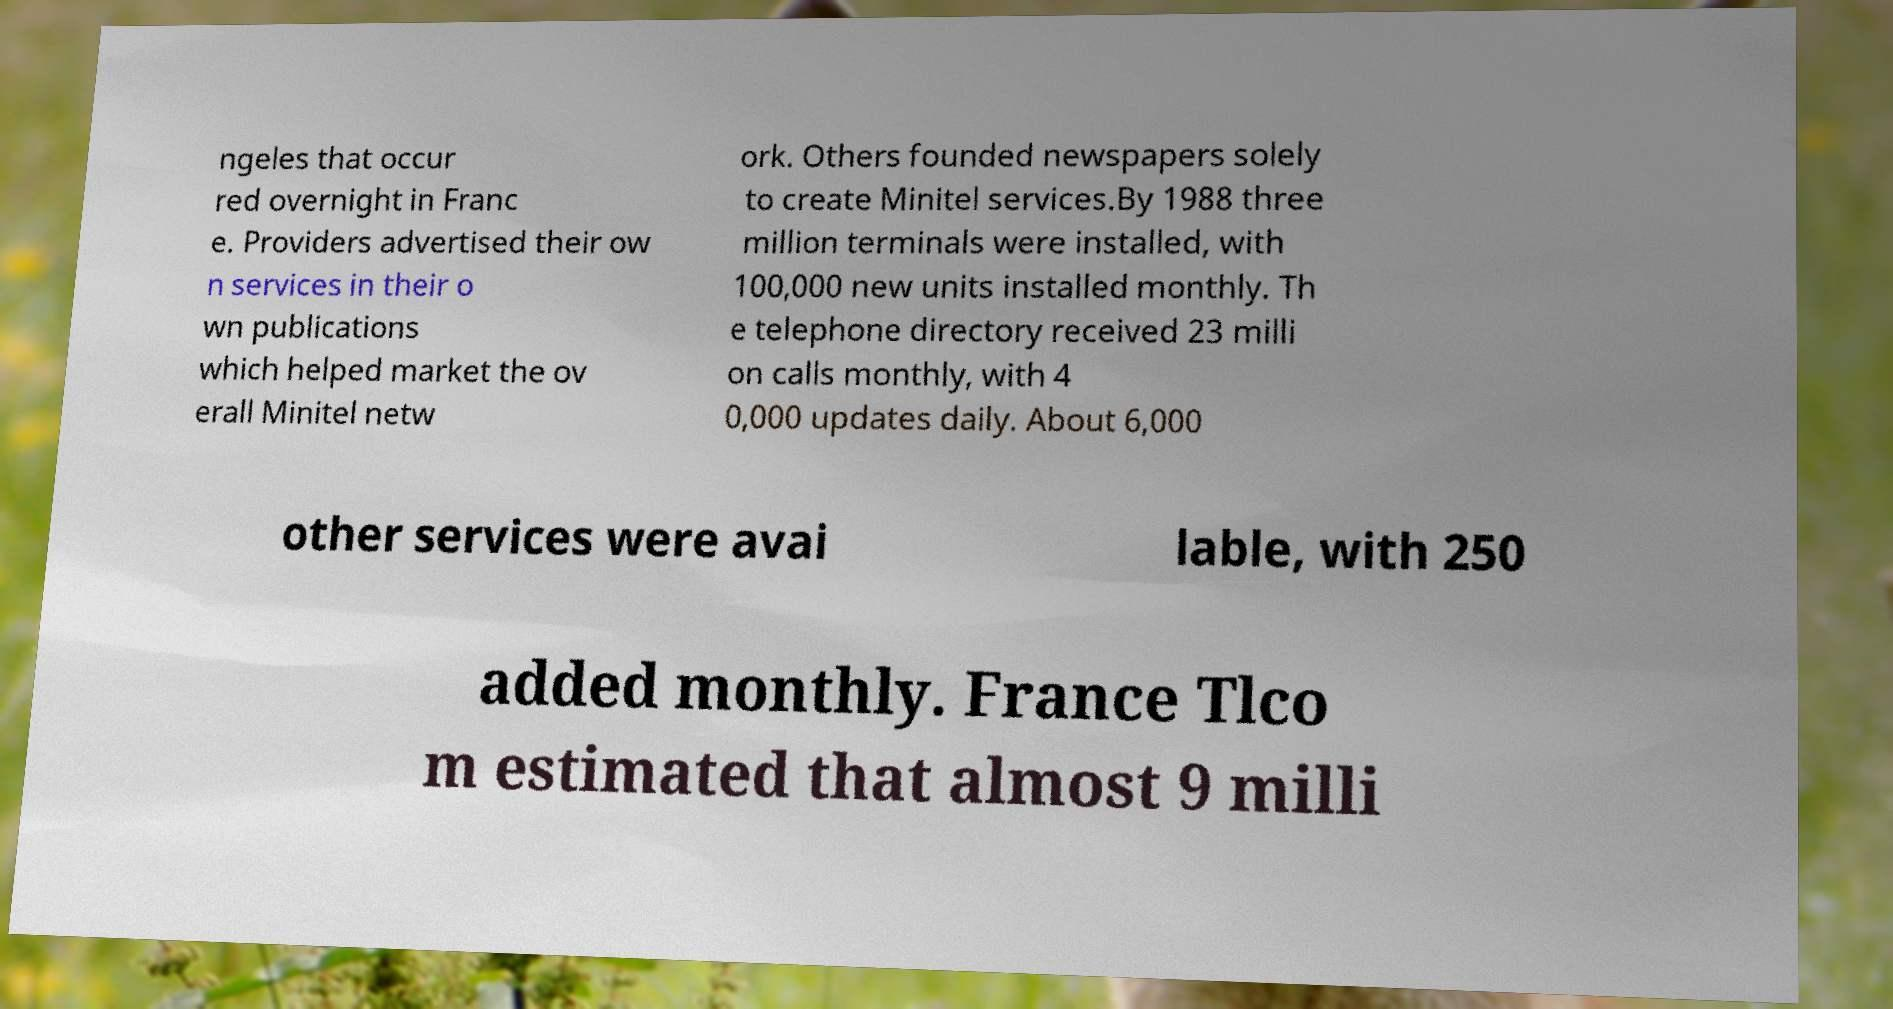What messages or text are displayed in this image? I need them in a readable, typed format. ngeles that occur red overnight in Franc e. Providers advertised their ow n services in their o wn publications which helped market the ov erall Minitel netw ork. Others founded newspapers solely to create Minitel services.By 1988 three million terminals were installed, with 100,000 new units installed monthly. Th e telephone directory received 23 milli on calls monthly, with 4 0,000 updates daily. About 6,000 other services were avai lable, with 250 added monthly. France Tlco m estimated that almost 9 milli 